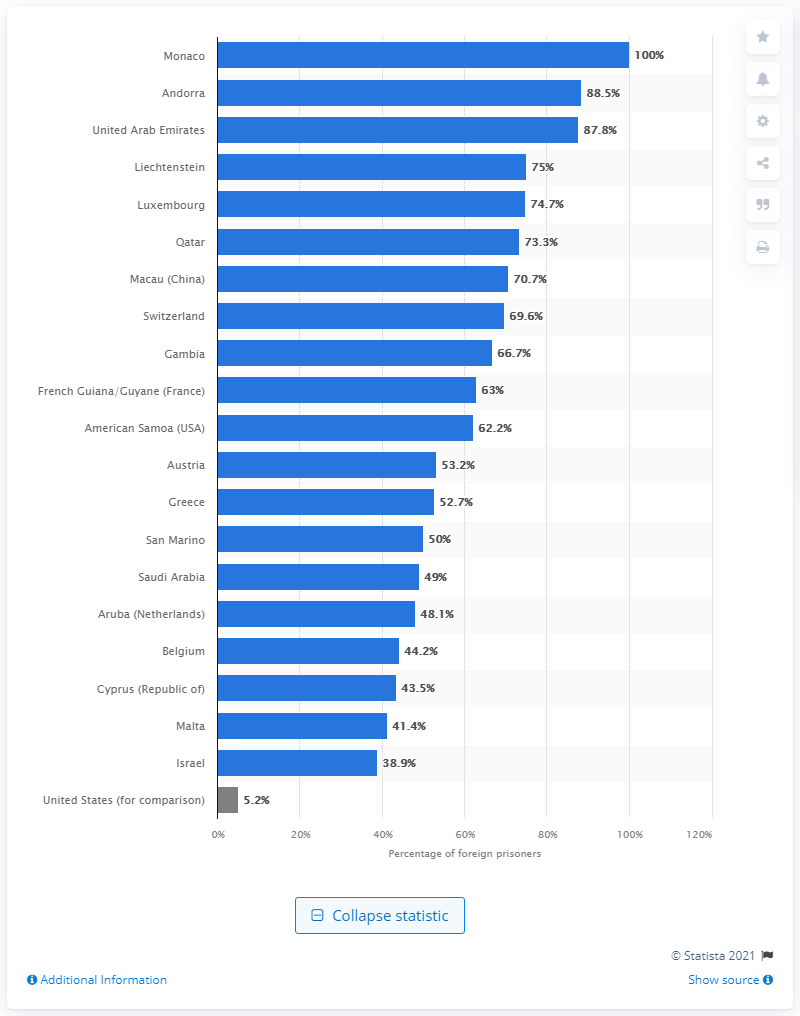Specify some key components in this picture. The country with the second highest percentage of foreign prisoners is Andorra. As of June 2020, Monaco had the highest percentage of foreign prisoners among all countries. 